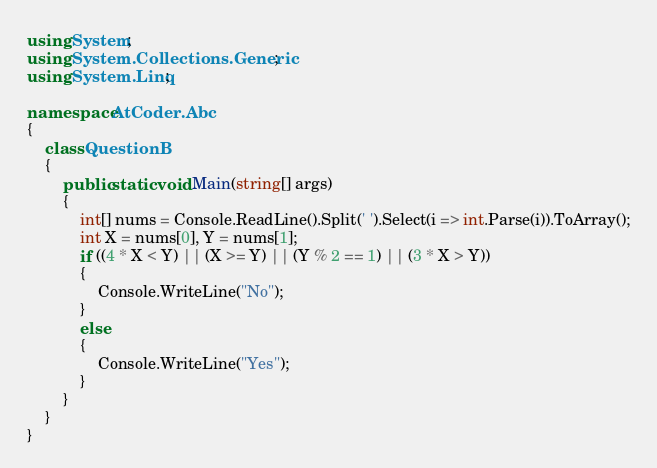Convert code to text. <code><loc_0><loc_0><loc_500><loc_500><_C#_>using System;
using System.Collections.Generic;
using System.Linq;

namespace AtCoder.Abc
{
    class QuestionB
    {
        public static void Main(string[] args)
        {
            int[] nums = Console.ReadLine().Split(' ').Select(i => int.Parse(i)).ToArray();
            int X = nums[0], Y = nums[1];
            if ((4 * X < Y) || (X >= Y) || (Y % 2 == 1) || (3 * X > Y))
            {
                Console.WriteLine("No");
            }
            else
            {
                Console.WriteLine("Yes");
            }
        }
    }
}
</code> 